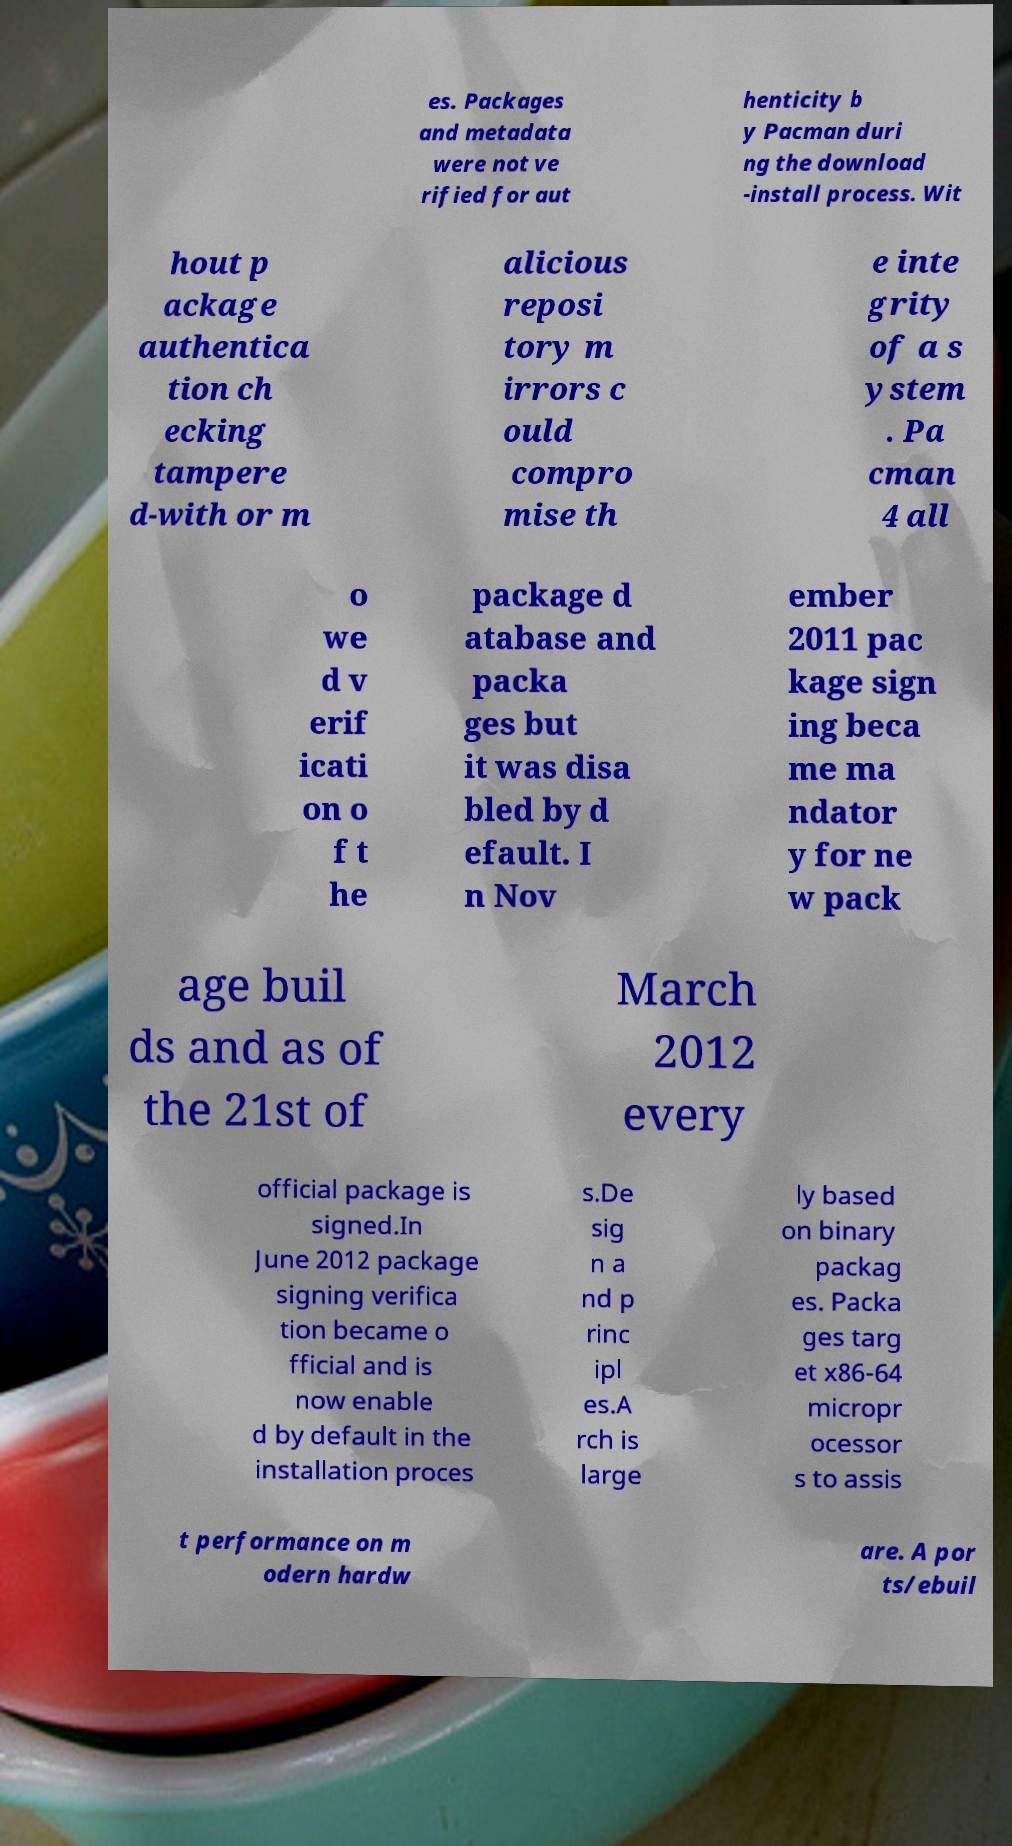Could you extract and type out the text from this image? es. Packages and metadata were not ve rified for aut henticity b y Pacman duri ng the download -install process. Wit hout p ackage authentica tion ch ecking tampere d-with or m alicious reposi tory m irrors c ould compro mise th e inte grity of a s ystem . Pa cman 4 all o we d v erif icati on o f t he package d atabase and packa ges but it was disa bled by d efault. I n Nov ember 2011 pac kage sign ing beca me ma ndator y for ne w pack age buil ds and as of the 21st of March 2012 every official package is signed.In June 2012 package signing verifica tion became o fficial and is now enable d by default in the installation proces s.De sig n a nd p rinc ipl es.A rch is large ly based on binary packag es. Packa ges targ et x86-64 micropr ocessor s to assis t performance on m odern hardw are. A por ts/ebuil 